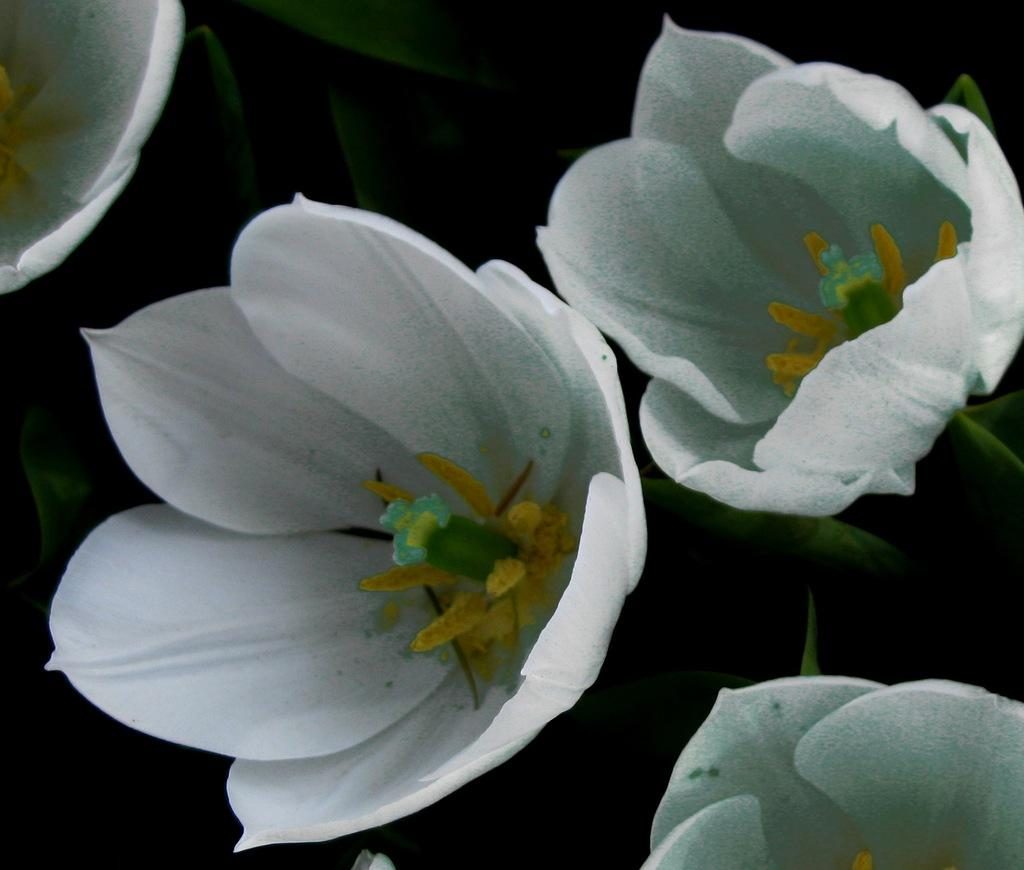What type of flowers can be seen in the image? There are white color flowers in the image. Can you see a swing in the image? No, there is no swing present in the image. Is there any salt visible in the image? No, there is no salt present in the image. 